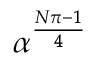<formula> <loc_0><loc_0><loc_500><loc_500>\alpha ^ { \frac { N \pi - 1 } { 4 } }</formula> 